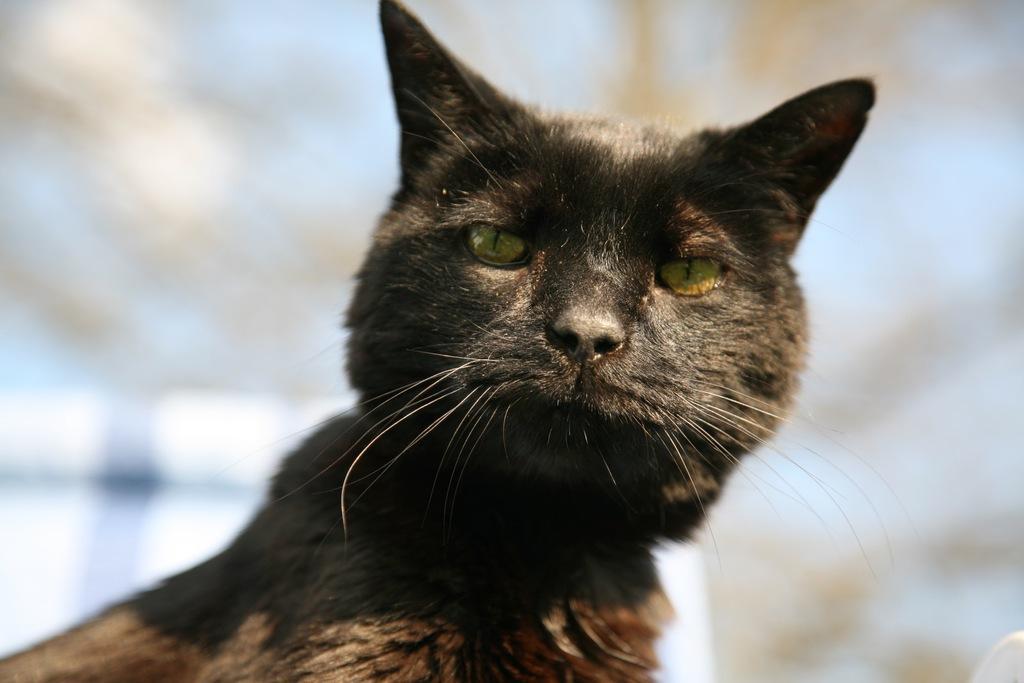In one or two sentences, can you explain what this image depicts? In this image we can see a cat. 